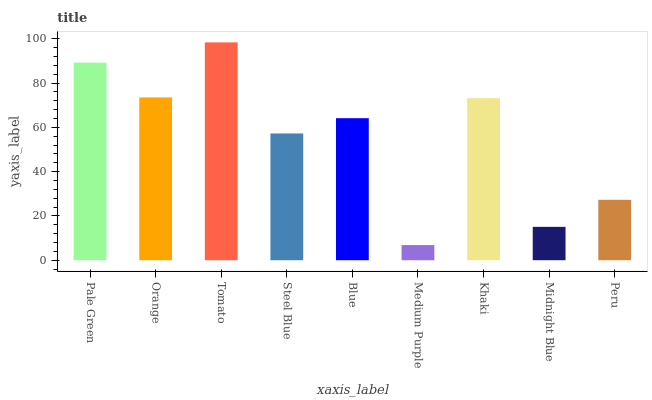Is Medium Purple the minimum?
Answer yes or no. Yes. Is Tomato the maximum?
Answer yes or no. Yes. Is Orange the minimum?
Answer yes or no. No. Is Orange the maximum?
Answer yes or no. No. Is Pale Green greater than Orange?
Answer yes or no. Yes. Is Orange less than Pale Green?
Answer yes or no. Yes. Is Orange greater than Pale Green?
Answer yes or no. No. Is Pale Green less than Orange?
Answer yes or no. No. Is Blue the high median?
Answer yes or no. Yes. Is Blue the low median?
Answer yes or no. Yes. Is Orange the high median?
Answer yes or no. No. Is Pale Green the low median?
Answer yes or no. No. 